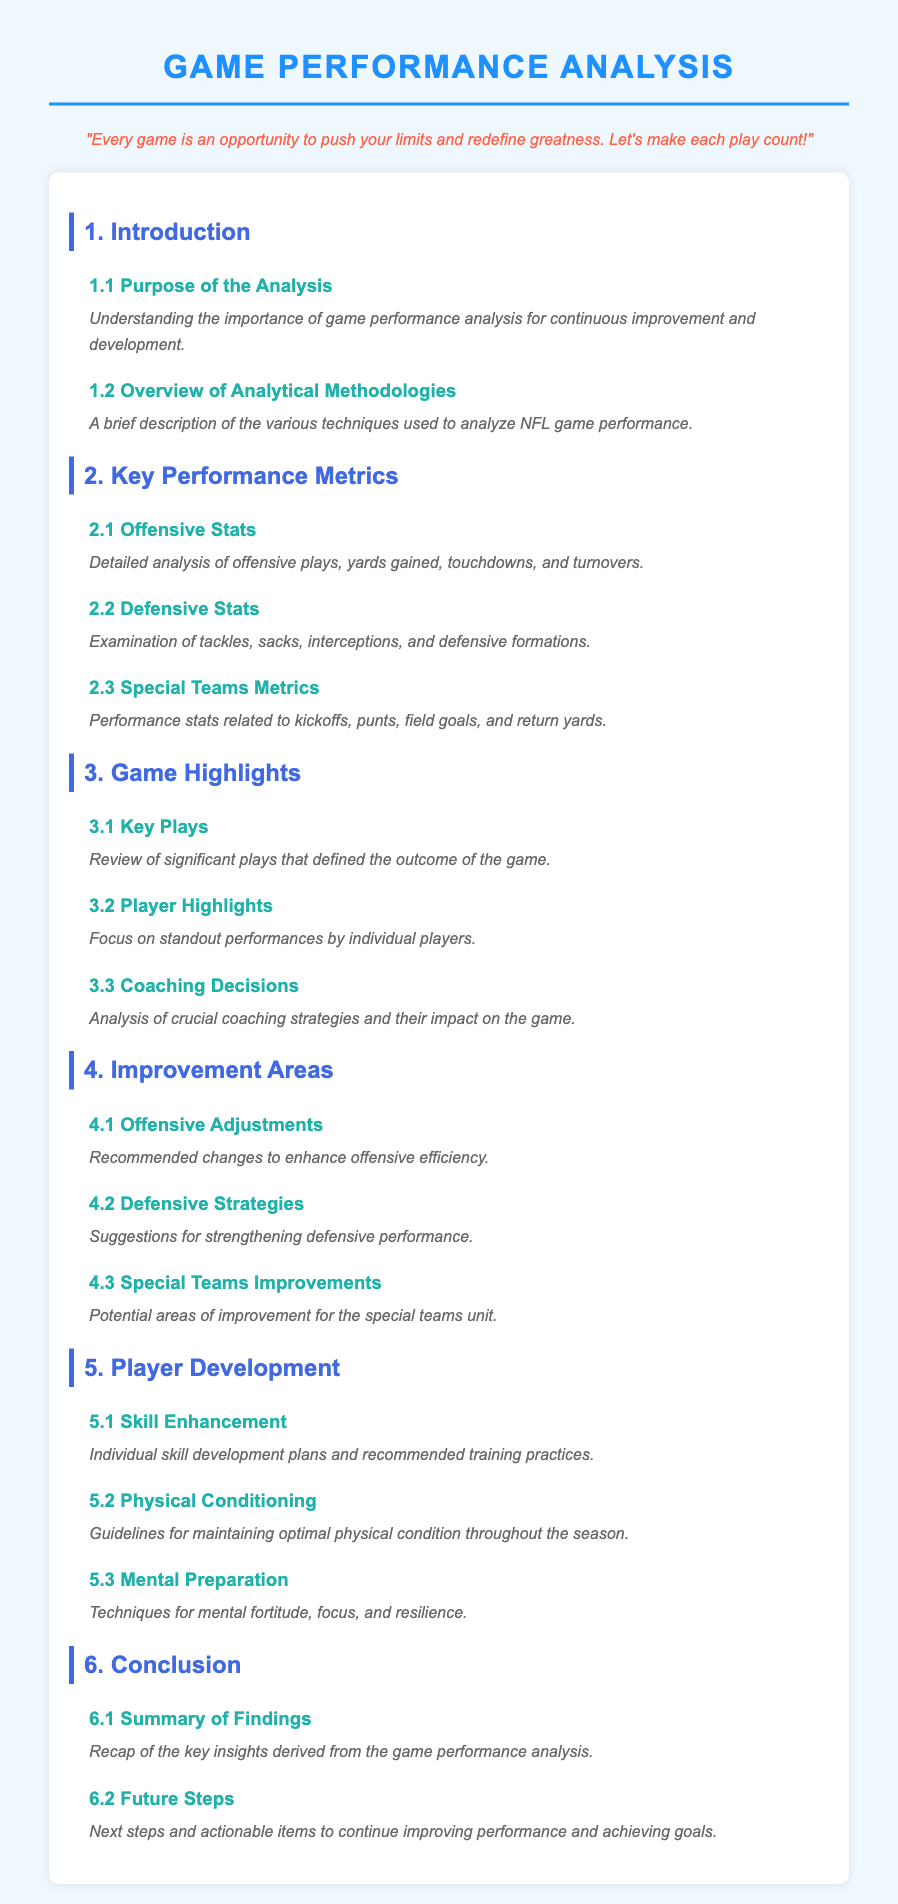What is the purpose of the analysis? The purpose of the analysis is to understand the importance of game performance analysis for continuous improvement and development.
Answer: Importance of game performance analysis What are the offensive stats analyzed? Offensive stats include detailed analysis of offensive plays, yards gained, touchdowns, and turnovers.
Answer: Offensive plays, yards gained, touchdowns, turnovers What section focuses on key plays? The section that focuses on key plays is "Game Highlights."
Answer: Game Highlights What is one area recommended for improvement in special teams? Recommended changes for special teams include potential areas of improvement for the special teams unit.
Answer: Potential areas of improvement What does the section on player development include? The section on player development includes individual skill development plans and recommended training practices.
Answer: Individual skill development plans How many sections are in the Table of Contents? The Table of Contents has six sections.
Answer: Six sections What is the title of the document? The title of the document is "Game Performance Analysis."
Answer: Game Performance Analysis What is the main focus of the improvement areas section? The main focus of the improvement areas section is to provide recommendations for enhancing performance.
Answer: Recommendations for enhancing performance 